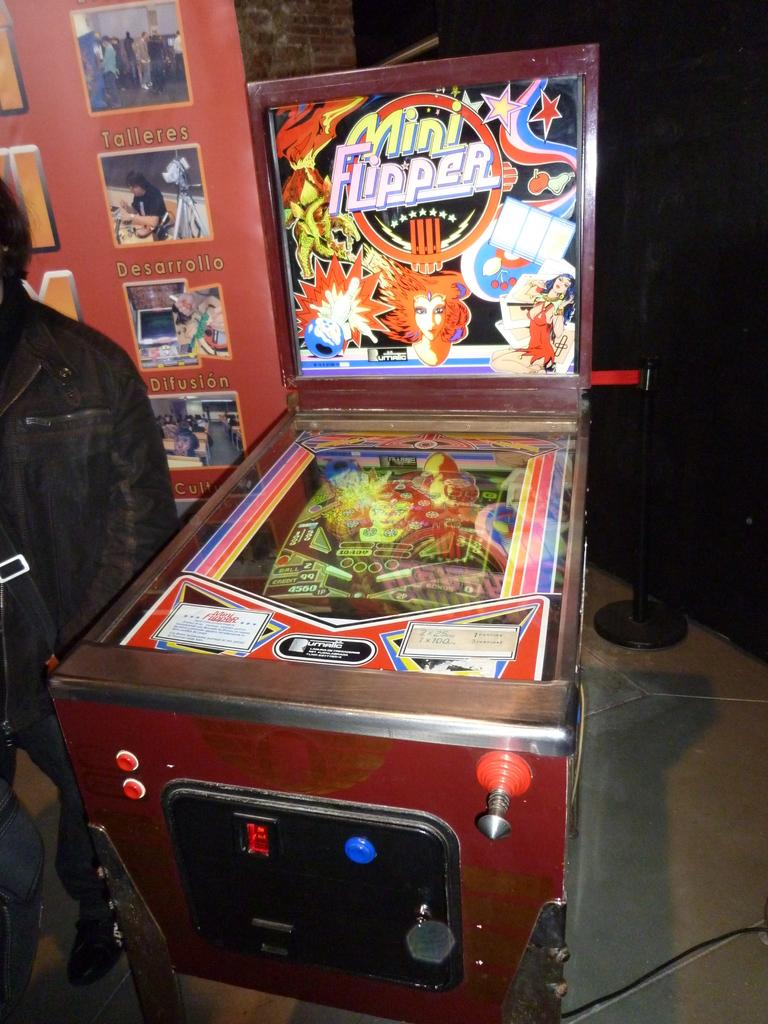What is the main object in the picture? There is a pinball machine in the picture. Is there anyone else in the picture besides the pinball machine? Yes, there is a person standing in the picture. What can be seen in the background of the picture? There is a board and a stanchion barrier in the background of the picture. What type of doctor is attending to the pinball machine in the image? There is no doctor present in the image, and the pinball machine does not require medical attention. 